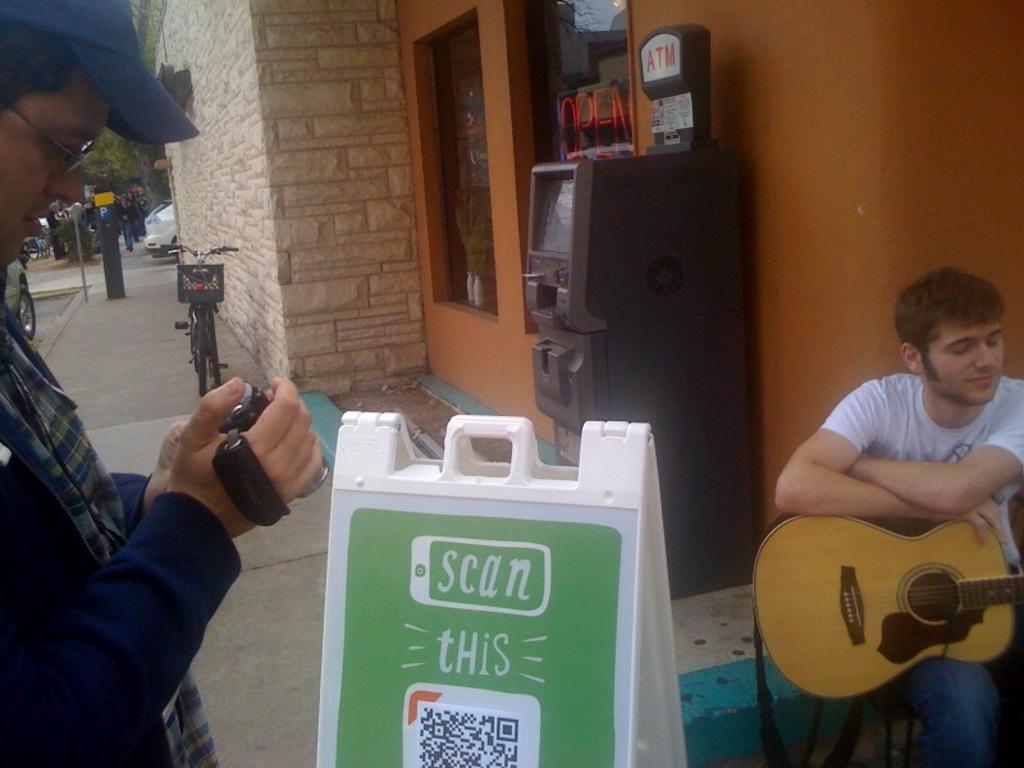Describe this image in one or two sentences. On the left side there is man who is looking to his camera. On the right side there is a person who is sitting on a chair and he is holding a yellow guitar. Besides him there is a atm machine. On the top there is a wall. Here its a bicycle. There is a car which is on a road. On the bottom there is a poster. 